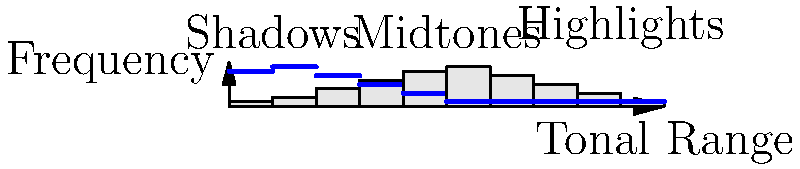As an Olympus camera user, you're analyzing two histograms for the same scene. The gray bars represent the current exposure, while the blue line shows an alternative exposure. Based on the histogram comparison, which of the following statements is true about the alternative exposure (blue line)? Let's analyze this step-by-step:

1. Understand the histogram: The x-axis represents the tonal range from shadows (left) to highlights (right), while the y-axis shows the frequency of pixels at each tonal value.

2. Compare the two histograms:
   - The gray bars (current exposure) show a relatively even distribution across the tonal range.
   - The blue line (alternative exposure) is shifted towards the left side of the histogram.

3. Interpret the shift:
   - A shift to the left means more pixels are in the shadow and dark midtone areas.
   - This indicates that the alternative exposure is darker overall.

4. Consider the implications:
   - The alternative exposure has reduced highlights (right side of the histogram).
   - It has increased shadow details (left side of the histogram).

5. Relate to photography terms:
   - This shift is typically achieved by reducing exposure (e.g., faster shutter speed, smaller aperture, or lower ISO).

6. Conclusion:
   The alternative exposure (blue line) represents a darker image with more shadow detail and less risk of highlight clipping compared to the current exposure (gray bars).
Answer: The alternative exposure is darker with more shadow detail. 